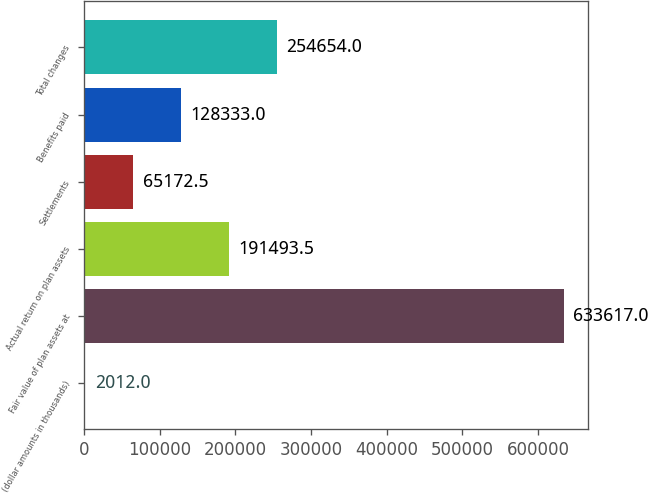Convert chart to OTSL. <chart><loc_0><loc_0><loc_500><loc_500><bar_chart><fcel>(dollar amounts in thousands)<fcel>Fair value of plan assets at<fcel>Actual return on plan assets<fcel>Settlements<fcel>Benefits paid<fcel>Total changes<nl><fcel>2012<fcel>633617<fcel>191494<fcel>65172.5<fcel>128333<fcel>254654<nl></chart> 